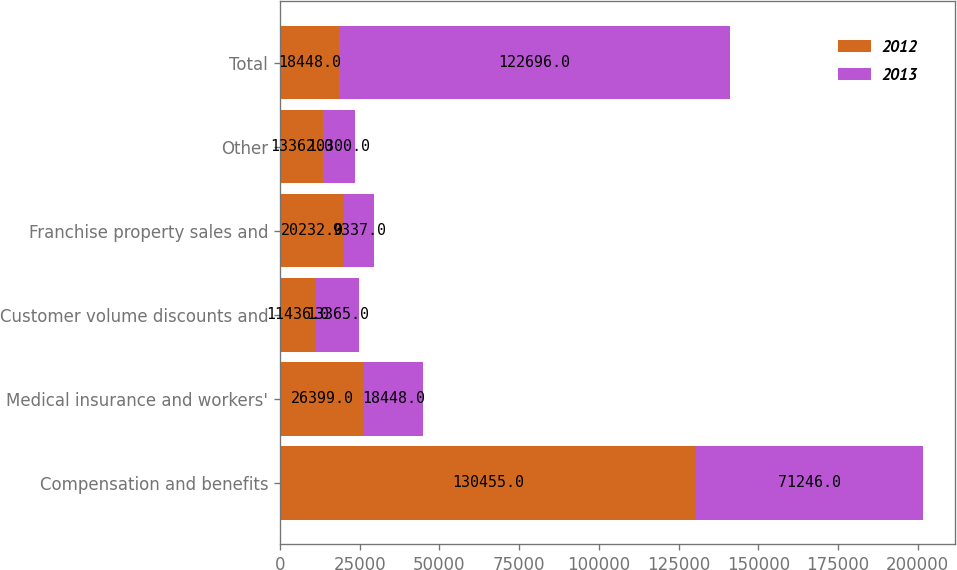<chart> <loc_0><loc_0><loc_500><loc_500><stacked_bar_chart><ecel><fcel>Compensation and benefits<fcel>Medical insurance and workers'<fcel>Customer volume discounts and<fcel>Franchise property sales and<fcel>Other<fcel>Total<nl><fcel>2012<fcel>130455<fcel>26399<fcel>11436<fcel>20232<fcel>13362<fcel>18448<nl><fcel>2013<fcel>71246<fcel>18448<fcel>13365<fcel>9337<fcel>10300<fcel>122696<nl></chart> 